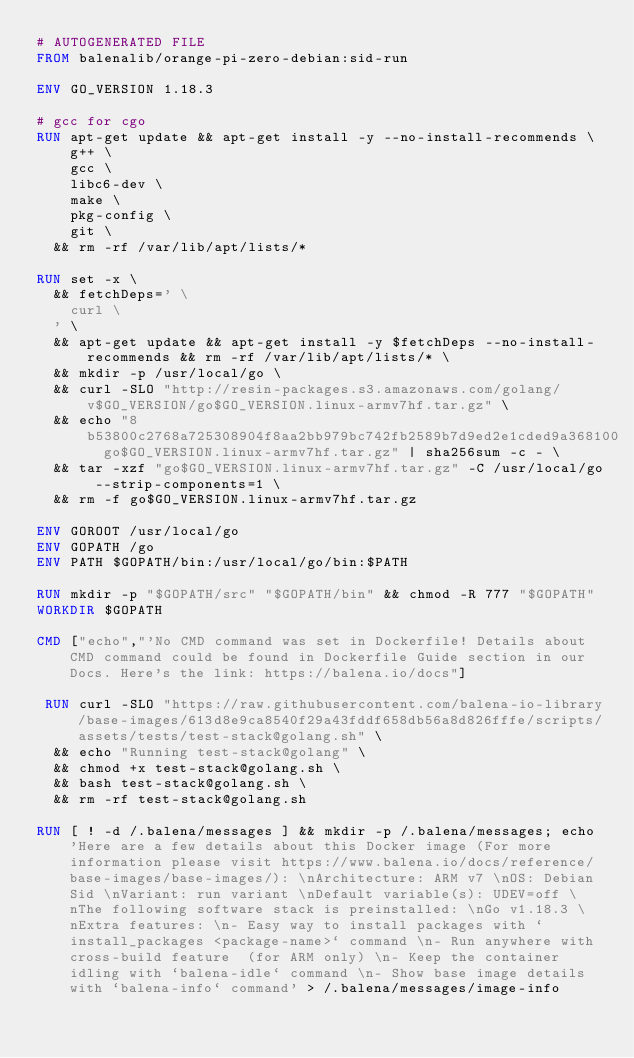<code> <loc_0><loc_0><loc_500><loc_500><_Dockerfile_># AUTOGENERATED FILE
FROM balenalib/orange-pi-zero-debian:sid-run

ENV GO_VERSION 1.18.3

# gcc for cgo
RUN apt-get update && apt-get install -y --no-install-recommends \
		g++ \
		gcc \
		libc6-dev \
		make \
		pkg-config \
		git \
	&& rm -rf /var/lib/apt/lists/*

RUN set -x \
	&& fetchDeps=' \
		curl \
	' \
	&& apt-get update && apt-get install -y $fetchDeps --no-install-recommends && rm -rf /var/lib/apt/lists/* \
	&& mkdir -p /usr/local/go \
	&& curl -SLO "http://resin-packages.s3.amazonaws.com/golang/v$GO_VERSION/go$GO_VERSION.linux-armv7hf.tar.gz" \
	&& echo "8b53800c2768a725308904f8aa2bb979bc742fb2589b7d9ed2e1cded9a368100  go$GO_VERSION.linux-armv7hf.tar.gz" | sha256sum -c - \
	&& tar -xzf "go$GO_VERSION.linux-armv7hf.tar.gz" -C /usr/local/go --strip-components=1 \
	&& rm -f go$GO_VERSION.linux-armv7hf.tar.gz

ENV GOROOT /usr/local/go
ENV GOPATH /go
ENV PATH $GOPATH/bin:/usr/local/go/bin:$PATH

RUN mkdir -p "$GOPATH/src" "$GOPATH/bin" && chmod -R 777 "$GOPATH"
WORKDIR $GOPATH

CMD ["echo","'No CMD command was set in Dockerfile! Details about CMD command could be found in Dockerfile Guide section in our Docs. Here's the link: https://balena.io/docs"]

 RUN curl -SLO "https://raw.githubusercontent.com/balena-io-library/base-images/613d8e9ca8540f29a43fddf658db56a8d826fffe/scripts/assets/tests/test-stack@golang.sh" \
  && echo "Running test-stack@golang" \
  && chmod +x test-stack@golang.sh \
  && bash test-stack@golang.sh \
  && rm -rf test-stack@golang.sh 

RUN [ ! -d /.balena/messages ] && mkdir -p /.balena/messages; echo 'Here are a few details about this Docker image (For more information please visit https://www.balena.io/docs/reference/base-images/base-images/): \nArchitecture: ARM v7 \nOS: Debian Sid \nVariant: run variant \nDefault variable(s): UDEV=off \nThe following software stack is preinstalled: \nGo v1.18.3 \nExtra features: \n- Easy way to install packages with `install_packages <package-name>` command \n- Run anywhere with cross-build feature  (for ARM only) \n- Keep the container idling with `balena-idle` command \n- Show base image details with `balena-info` command' > /.balena/messages/image-info</code> 